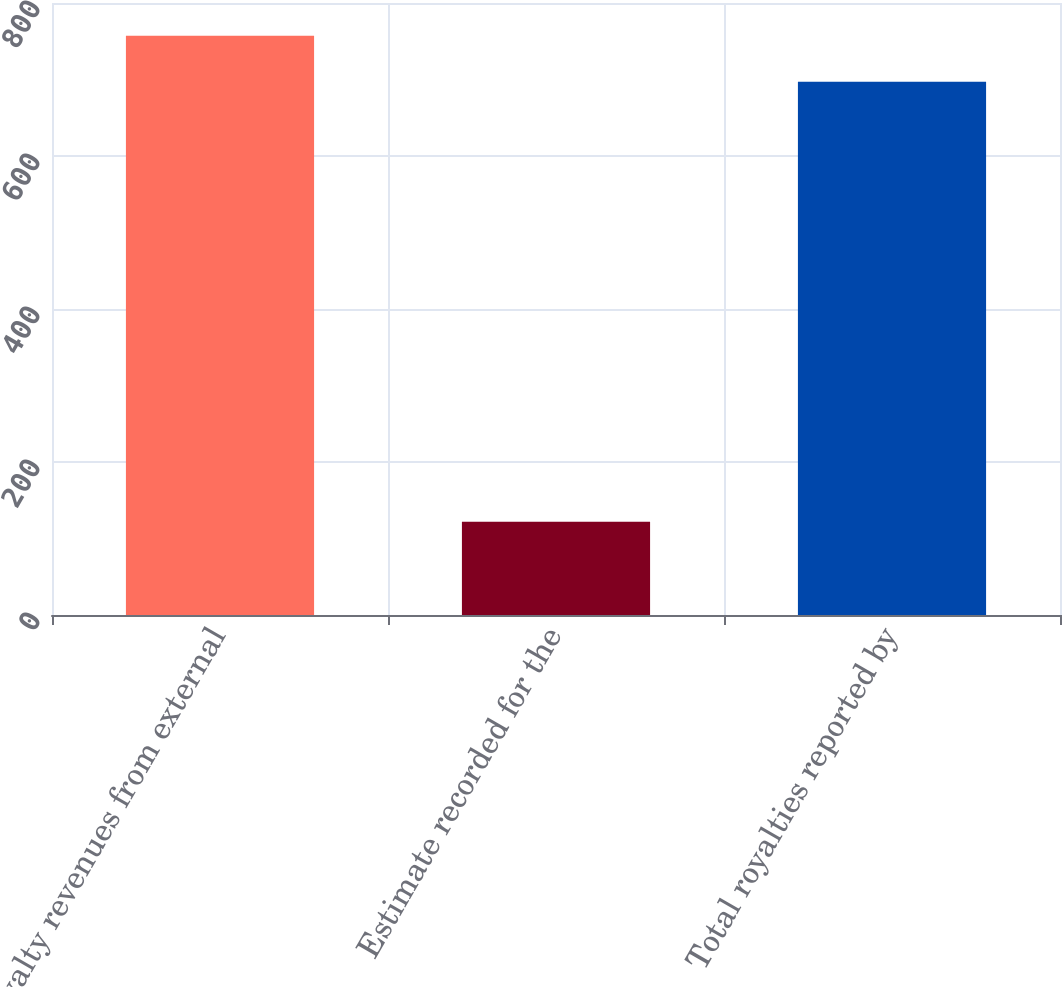<chart> <loc_0><loc_0><loc_500><loc_500><bar_chart><fcel>Royalty revenues from external<fcel>Estimate recorded for the<fcel>Total royalties reported by<nl><fcel>757.3<fcel>122<fcel>697<nl></chart> 